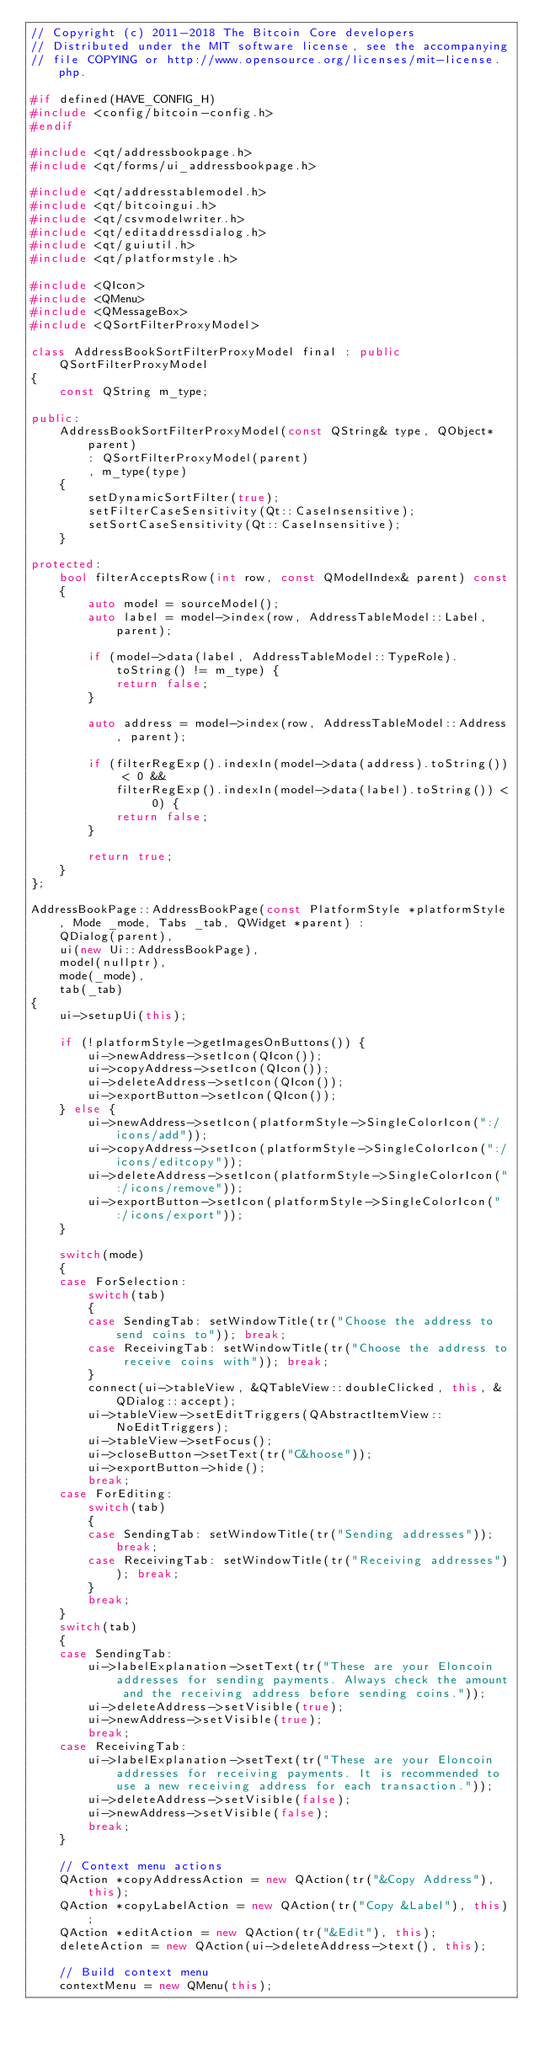<code> <loc_0><loc_0><loc_500><loc_500><_C++_>// Copyright (c) 2011-2018 The Bitcoin Core developers
// Distributed under the MIT software license, see the accompanying
// file COPYING or http://www.opensource.org/licenses/mit-license.php.

#if defined(HAVE_CONFIG_H)
#include <config/bitcoin-config.h>
#endif

#include <qt/addressbookpage.h>
#include <qt/forms/ui_addressbookpage.h>

#include <qt/addresstablemodel.h>
#include <qt/bitcoingui.h>
#include <qt/csvmodelwriter.h>
#include <qt/editaddressdialog.h>
#include <qt/guiutil.h>
#include <qt/platformstyle.h>

#include <QIcon>
#include <QMenu>
#include <QMessageBox>
#include <QSortFilterProxyModel>

class AddressBookSortFilterProxyModel final : public QSortFilterProxyModel
{
    const QString m_type;

public:
    AddressBookSortFilterProxyModel(const QString& type, QObject* parent)
        : QSortFilterProxyModel(parent)
        , m_type(type)
    {
        setDynamicSortFilter(true);
        setFilterCaseSensitivity(Qt::CaseInsensitive);
        setSortCaseSensitivity(Qt::CaseInsensitive);
    }

protected:
    bool filterAcceptsRow(int row, const QModelIndex& parent) const
    {
        auto model = sourceModel();
        auto label = model->index(row, AddressTableModel::Label, parent);

        if (model->data(label, AddressTableModel::TypeRole).toString() != m_type) {
            return false;
        }

        auto address = model->index(row, AddressTableModel::Address, parent);

        if (filterRegExp().indexIn(model->data(address).toString()) < 0 &&
            filterRegExp().indexIn(model->data(label).toString()) < 0) {
            return false;
        }

        return true;
    }
};

AddressBookPage::AddressBookPage(const PlatformStyle *platformStyle, Mode _mode, Tabs _tab, QWidget *parent) :
    QDialog(parent),
    ui(new Ui::AddressBookPage),
    model(nullptr),
    mode(_mode),
    tab(_tab)
{
    ui->setupUi(this);

    if (!platformStyle->getImagesOnButtons()) {
        ui->newAddress->setIcon(QIcon());
        ui->copyAddress->setIcon(QIcon());
        ui->deleteAddress->setIcon(QIcon());
        ui->exportButton->setIcon(QIcon());
    } else {
        ui->newAddress->setIcon(platformStyle->SingleColorIcon(":/icons/add"));
        ui->copyAddress->setIcon(platformStyle->SingleColorIcon(":/icons/editcopy"));
        ui->deleteAddress->setIcon(platformStyle->SingleColorIcon(":/icons/remove"));
        ui->exportButton->setIcon(platformStyle->SingleColorIcon(":/icons/export"));
    }

    switch(mode)
    {
    case ForSelection:
        switch(tab)
        {
        case SendingTab: setWindowTitle(tr("Choose the address to send coins to")); break;
        case ReceivingTab: setWindowTitle(tr("Choose the address to receive coins with")); break;
        }
        connect(ui->tableView, &QTableView::doubleClicked, this, &QDialog::accept);
        ui->tableView->setEditTriggers(QAbstractItemView::NoEditTriggers);
        ui->tableView->setFocus();
        ui->closeButton->setText(tr("C&hoose"));
        ui->exportButton->hide();
        break;
    case ForEditing:
        switch(tab)
        {
        case SendingTab: setWindowTitle(tr("Sending addresses")); break;
        case ReceivingTab: setWindowTitle(tr("Receiving addresses")); break;
        }
        break;
    }
    switch(tab)
    {
    case SendingTab:
        ui->labelExplanation->setText(tr("These are your Eloncoin addresses for sending payments. Always check the amount and the receiving address before sending coins."));
        ui->deleteAddress->setVisible(true);
        ui->newAddress->setVisible(true);
        break;
    case ReceivingTab:
        ui->labelExplanation->setText(tr("These are your Eloncoin addresses for receiving payments. It is recommended to use a new receiving address for each transaction."));
        ui->deleteAddress->setVisible(false);
        ui->newAddress->setVisible(false);
        break;
    }

    // Context menu actions
    QAction *copyAddressAction = new QAction(tr("&Copy Address"), this);
    QAction *copyLabelAction = new QAction(tr("Copy &Label"), this);
    QAction *editAction = new QAction(tr("&Edit"), this);
    deleteAction = new QAction(ui->deleteAddress->text(), this);

    // Build context menu
    contextMenu = new QMenu(this);</code> 